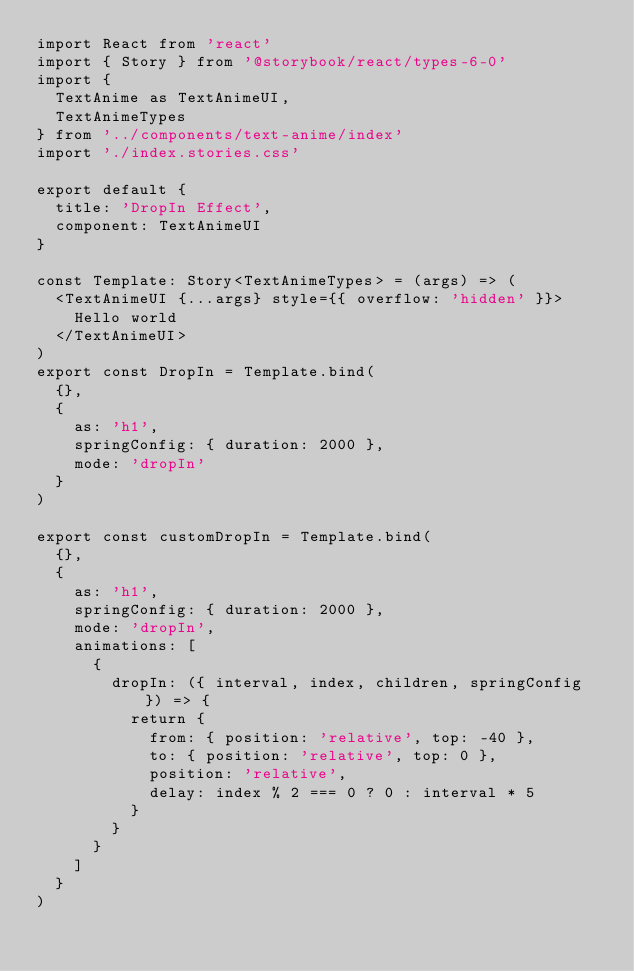<code> <loc_0><loc_0><loc_500><loc_500><_TypeScript_>import React from 'react'
import { Story } from '@storybook/react/types-6-0'
import {
  TextAnime as TextAnimeUI,
  TextAnimeTypes
} from '../components/text-anime/index'
import './index.stories.css'

export default {
  title: 'DropIn Effect',
  component: TextAnimeUI
}

const Template: Story<TextAnimeTypes> = (args) => (
  <TextAnimeUI {...args} style={{ overflow: 'hidden' }}>
    Hello world
  </TextAnimeUI>
)
export const DropIn = Template.bind(
  {},
  {
    as: 'h1',
    springConfig: { duration: 2000 },
    mode: 'dropIn'
  }
)

export const customDropIn = Template.bind(
  {},
  {
    as: 'h1',
    springConfig: { duration: 2000 },
    mode: 'dropIn',
    animations: [
      {
        dropIn: ({ interval, index, children, springConfig }) => {
          return {
            from: { position: 'relative', top: -40 },
            to: { position: 'relative', top: 0 },
            position: 'relative',
            delay: index % 2 === 0 ? 0 : interval * 5
          }
        }
      }
    ]
  }
)
</code> 